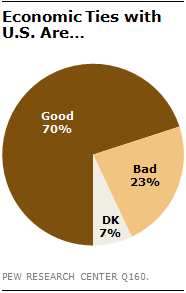Highlight a few significant elements in this photo. The largest segment is ten times larger than the smallest segment. Seventy percent is a significant proportion of positive opinions. 